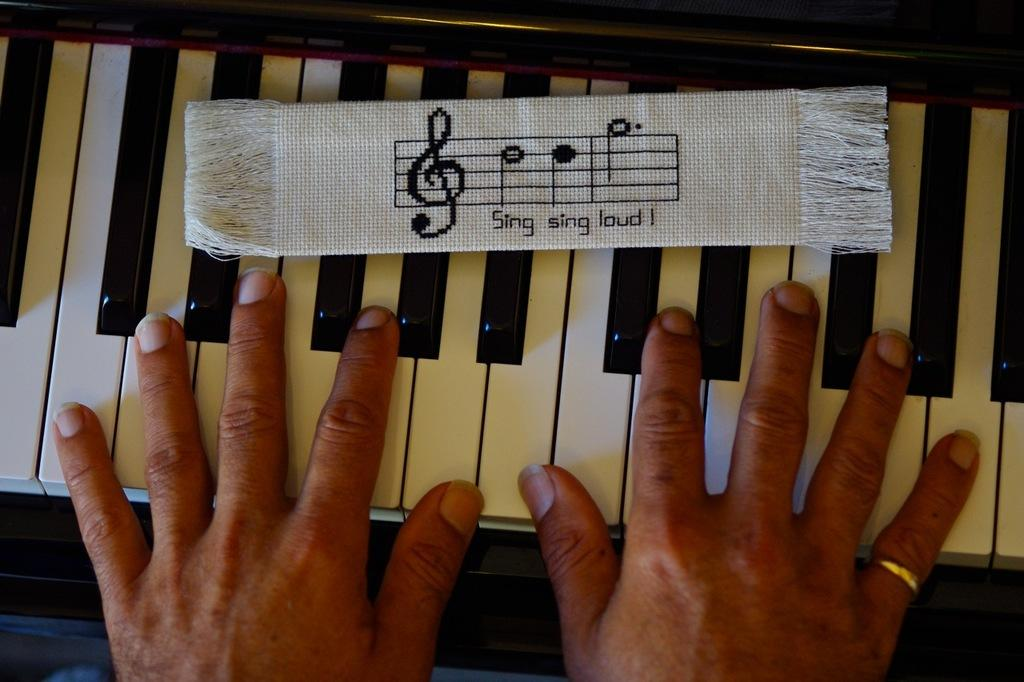What is the main subject of the image? The main subject of the image is human hands on a piano. What else can be seen in the image besides the hands on the piano? There is a cloth visible in the image. What type of polish is being applied to the face in the image? There is no face or polish present in the image; it features human hands on a piano and a cloth. What is the cause of death for the person in the image? There is no person or indication of death present in the image. 